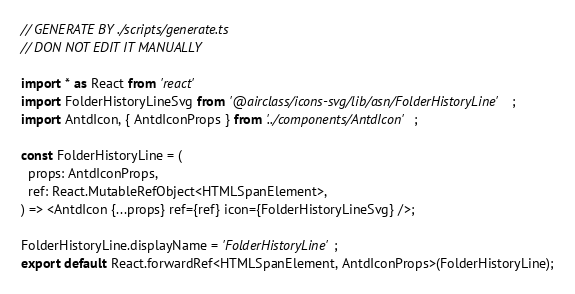<code> <loc_0><loc_0><loc_500><loc_500><_TypeScript_>// GENERATE BY ./scripts/generate.ts
// DON NOT EDIT IT MANUALLY

import * as React from 'react'
import FolderHistoryLineSvg from '@airclass/icons-svg/lib/asn/FolderHistoryLine';
import AntdIcon, { AntdIconProps } from '../components/AntdIcon';

const FolderHistoryLine = (
  props: AntdIconProps,
  ref: React.MutableRefObject<HTMLSpanElement>,
) => <AntdIcon {...props} ref={ref} icon={FolderHistoryLineSvg} />;

FolderHistoryLine.displayName = 'FolderHistoryLine';
export default React.forwardRef<HTMLSpanElement, AntdIconProps>(FolderHistoryLine);</code> 